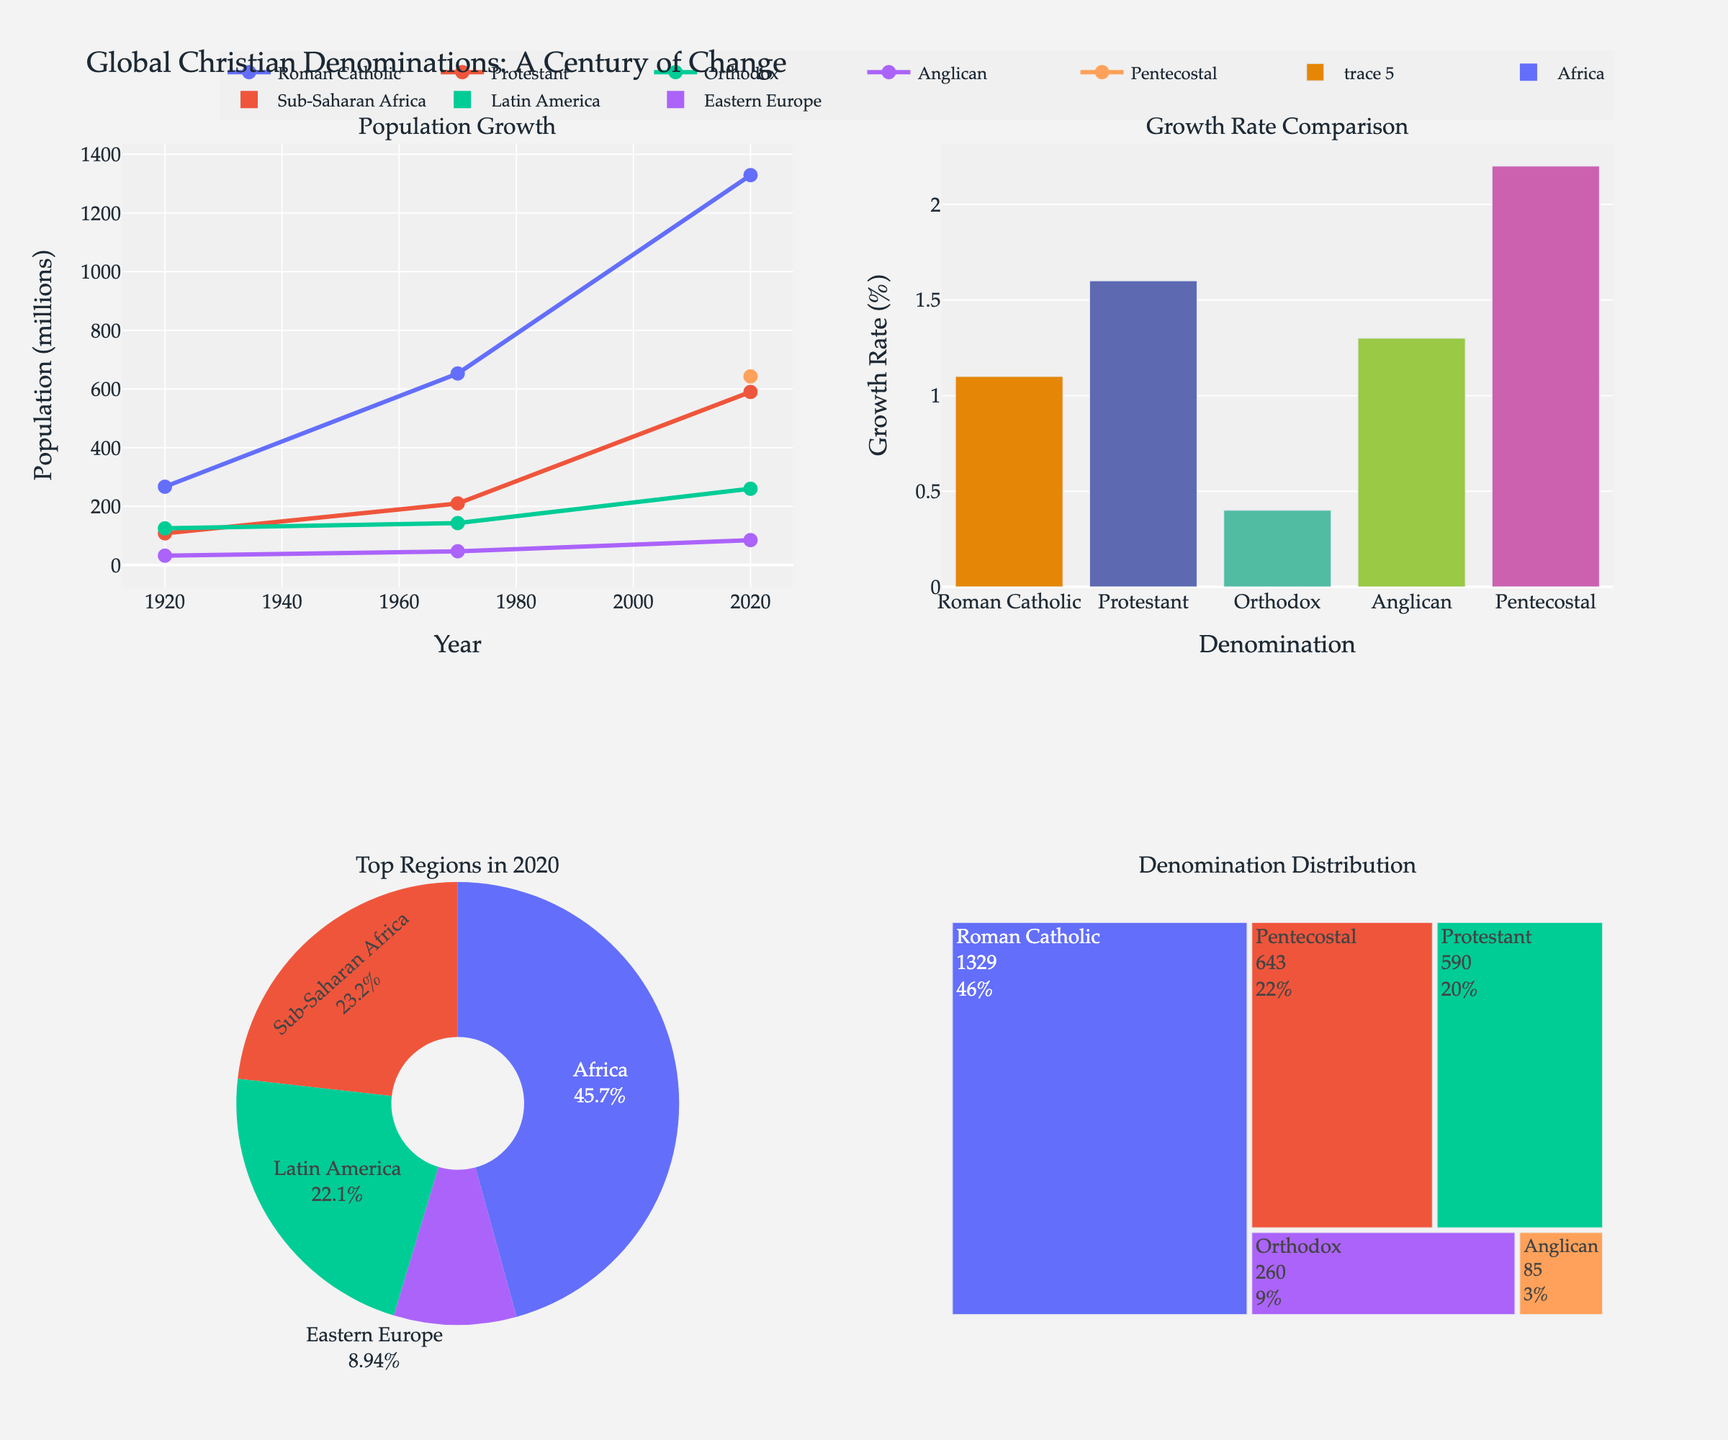What is the total population of Roman Catholics in 2020 in millions? The treemap in the bottom right corner shows the denominations and their populations in 2020. Roman Catholics have a population of 1329 million.
Answer: 1329 million Which denomination has the highest growth rate in 2020? The bar chart in the top right corner compares the growth rates of different denominations in 2020. Pentecostal has the highest growth rate at 2.2%.
Answer: Pentecostal How has the population of Anglicans changed from 1970 to 2020? Looking at the line chart in the top left corner, the population of Anglicans increased from 47 million in 1970 to 85 million in 2020.
Answer: Increased from 47 million to 85 million Which region had the highest population of Orthodox Christians in 2020? The pie chart in the bottom left corner shows the top regions for each denomination in 2020. Eastern Europe is the top region for Orthodox Christians.
Answer: Eastern Europe What percentage of the total Christian population in 2020 does the Protestant denomination represent? From the pie chart, compare the Protestant population of 590 million to the total of all denominations, which is 1329 (Roman Catholic) + 590 (Protestant) + 260 (Orthodox) + 85 (Anglican) + 643 (Pentecostal) = 2907 million. Therefore, the percentage is (590 / 2907) × 100 ≈ 20.3%.
Answer: 20.3% Which denomination experienced the highest population growth from 1920 to 2020? Examining the line chart in the top left corner, the population of Roman Catholics grew from 267 million in 1920 to 1329 million in 2020, an increase of 1062 million. This is the highest growth among the denominations.
Answer: Roman Catholic What is the trend in the growth rate of the Orthodox denomination over the century? The line chart in the top left corner shows the Orthodox population in 1920, 1970, and 2020. The bar chart in the top right corner shows their growth rates over these periods. The growth rate of the Orthodox denomination has decreased from 0.8% in 1920 to 0.4% in 2020.
Answer: Decreasing Which denomination had the smallest population in 1920 and what was it? The line chart in the top left corner shows that the Anglican denomination had the smallest population in 1920, with 32 million people.
Answer: Anglican, 32 million What proportion of the global Christian population does Sub-Saharan Africa represent in 2020 for Protestants? The pie chart in the bottom left corner and the population data from the treemap indicate that Sub-Saharan Africa is the top region for Protestants in 2020 with a population of 590 million out of 2907 million total Christians. This gives a proportion of (590 / 2907) × 100 ≈ 20.3%.
Answer: 20.3% 